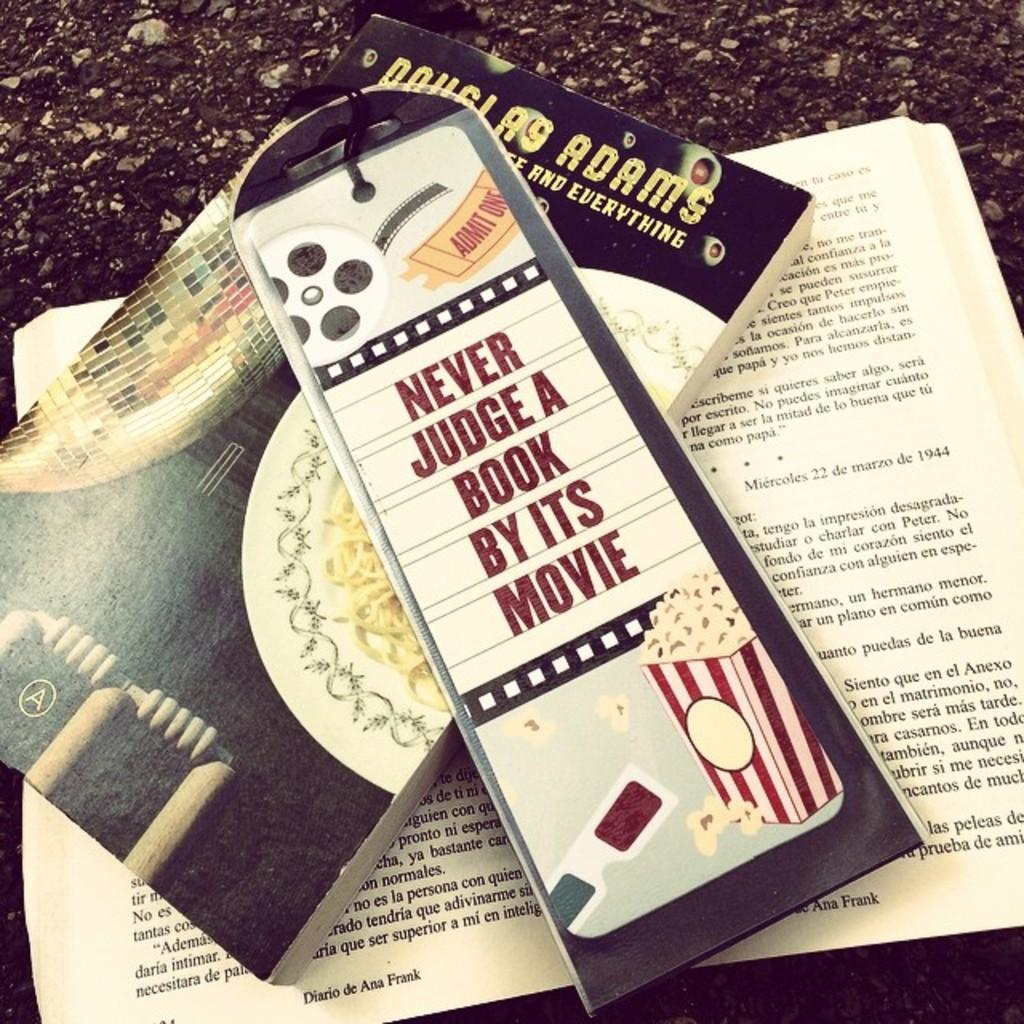Provide a one-sentence caption for the provided image. A bookmark that reads never judge a book by its movie and a book underneath. 